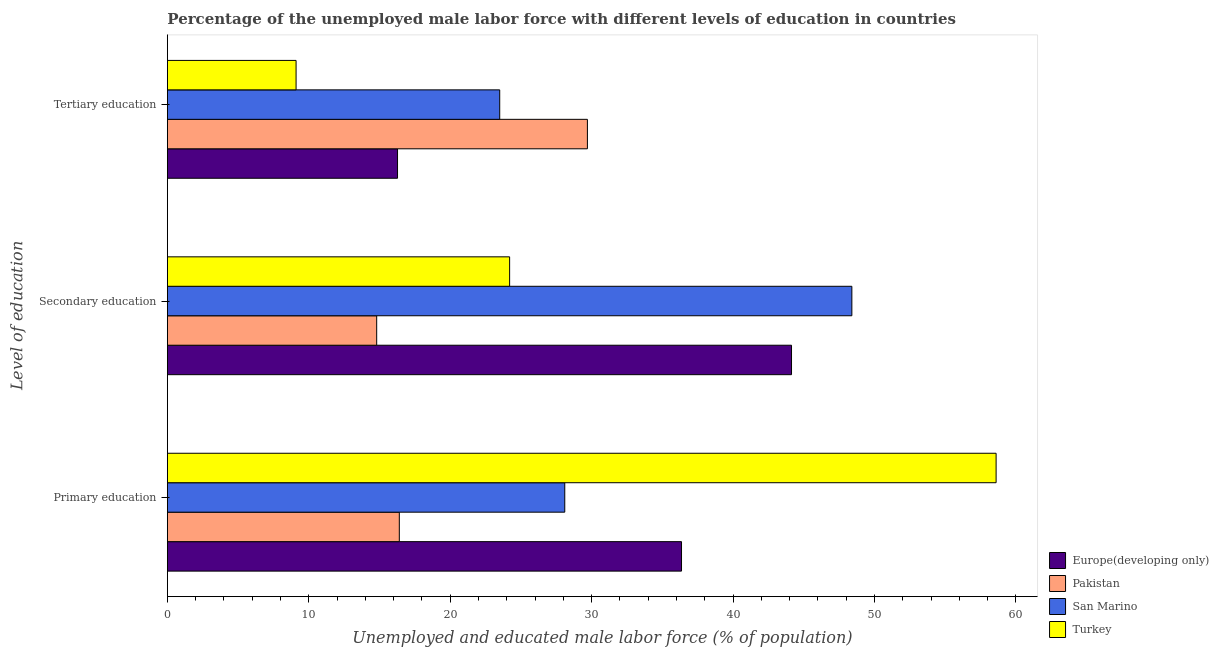Are the number of bars per tick equal to the number of legend labels?
Your answer should be very brief. Yes. How many bars are there on the 2nd tick from the bottom?
Offer a terse response. 4. What is the label of the 1st group of bars from the top?
Offer a terse response. Tertiary education. What is the percentage of male labor force who received secondary education in Pakistan?
Give a very brief answer. 14.8. Across all countries, what is the maximum percentage of male labor force who received secondary education?
Provide a short and direct response. 48.4. Across all countries, what is the minimum percentage of male labor force who received primary education?
Make the answer very short. 16.4. In which country was the percentage of male labor force who received primary education maximum?
Your response must be concise. Turkey. What is the total percentage of male labor force who received primary education in the graph?
Give a very brief answer. 139.46. What is the difference between the percentage of male labor force who received primary education in Pakistan and that in San Marino?
Your answer should be very brief. -11.7. What is the difference between the percentage of male labor force who received tertiary education in Europe(developing only) and the percentage of male labor force who received secondary education in San Marino?
Offer a very short reply. -32.13. What is the average percentage of male labor force who received tertiary education per country?
Offer a terse response. 19.64. What is the difference between the percentage of male labor force who received tertiary education and percentage of male labor force who received secondary education in Turkey?
Keep it short and to the point. -15.1. What is the ratio of the percentage of male labor force who received tertiary education in Europe(developing only) to that in San Marino?
Your response must be concise. 0.69. Is the percentage of male labor force who received secondary education in San Marino less than that in Turkey?
Provide a succinct answer. No. What is the difference between the highest and the second highest percentage of male labor force who received tertiary education?
Provide a short and direct response. 6.2. What is the difference between the highest and the lowest percentage of male labor force who received tertiary education?
Give a very brief answer. 20.6. What does the 2nd bar from the top in Primary education represents?
Provide a short and direct response. San Marino. What does the 2nd bar from the bottom in Primary education represents?
Your answer should be compact. Pakistan. How many bars are there?
Give a very brief answer. 12. Are all the bars in the graph horizontal?
Make the answer very short. Yes. How many countries are there in the graph?
Offer a terse response. 4. What is the difference between two consecutive major ticks on the X-axis?
Provide a succinct answer. 10. Are the values on the major ticks of X-axis written in scientific E-notation?
Make the answer very short. No. Does the graph contain grids?
Keep it short and to the point. No. What is the title of the graph?
Ensure brevity in your answer.  Percentage of the unemployed male labor force with different levels of education in countries. Does "Tanzania" appear as one of the legend labels in the graph?
Provide a short and direct response. No. What is the label or title of the X-axis?
Give a very brief answer. Unemployed and educated male labor force (% of population). What is the label or title of the Y-axis?
Offer a very short reply. Level of education. What is the Unemployed and educated male labor force (% of population) in Europe(developing only) in Primary education?
Your answer should be very brief. 36.36. What is the Unemployed and educated male labor force (% of population) in Pakistan in Primary education?
Provide a short and direct response. 16.4. What is the Unemployed and educated male labor force (% of population) of San Marino in Primary education?
Offer a very short reply. 28.1. What is the Unemployed and educated male labor force (% of population) in Turkey in Primary education?
Provide a succinct answer. 58.6. What is the Unemployed and educated male labor force (% of population) in Europe(developing only) in Secondary education?
Give a very brief answer. 44.13. What is the Unemployed and educated male labor force (% of population) in Pakistan in Secondary education?
Offer a very short reply. 14.8. What is the Unemployed and educated male labor force (% of population) of San Marino in Secondary education?
Provide a short and direct response. 48.4. What is the Unemployed and educated male labor force (% of population) of Turkey in Secondary education?
Make the answer very short. 24.2. What is the Unemployed and educated male labor force (% of population) in Europe(developing only) in Tertiary education?
Make the answer very short. 16.27. What is the Unemployed and educated male labor force (% of population) of Pakistan in Tertiary education?
Ensure brevity in your answer.  29.7. What is the Unemployed and educated male labor force (% of population) in San Marino in Tertiary education?
Make the answer very short. 23.5. What is the Unemployed and educated male labor force (% of population) in Turkey in Tertiary education?
Your answer should be very brief. 9.1. Across all Level of education, what is the maximum Unemployed and educated male labor force (% of population) in Europe(developing only)?
Ensure brevity in your answer.  44.13. Across all Level of education, what is the maximum Unemployed and educated male labor force (% of population) of Pakistan?
Provide a succinct answer. 29.7. Across all Level of education, what is the maximum Unemployed and educated male labor force (% of population) of San Marino?
Keep it short and to the point. 48.4. Across all Level of education, what is the maximum Unemployed and educated male labor force (% of population) in Turkey?
Make the answer very short. 58.6. Across all Level of education, what is the minimum Unemployed and educated male labor force (% of population) in Europe(developing only)?
Provide a succinct answer. 16.27. Across all Level of education, what is the minimum Unemployed and educated male labor force (% of population) of Pakistan?
Your response must be concise. 14.8. Across all Level of education, what is the minimum Unemployed and educated male labor force (% of population) in San Marino?
Give a very brief answer. 23.5. Across all Level of education, what is the minimum Unemployed and educated male labor force (% of population) in Turkey?
Your response must be concise. 9.1. What is the total Unemployed and educated male labor force (% of population) in Europe(developing only) in the graph?
Give a very brief answer. 96.76. What is the total Unemployed and educated male labor force (% of population) of Pakistan in the graph?
Provide a succinct answer. 60.9. What is the total Unemployed and educated male labor force (% of population) in San Marino in the graph?
Your answer should be very brief. 100. What is the total Unemployed and educated male labor force (% of population) in Turkey in the graph?
Your answer should be compact. 91.9. What is the difference between the Unemployed and educated male labor force (% of population) in Europe(developing only) in Primary education and that in Secondary education?
Keep it short and to the point. -7.78. What is the difference between the Unemployed and educated male labor force (% of population) of Pakistan in Primary education and that in Secondary education?
Give a very brief answer. 1.6. What is the difference between the Unemployed and educated male labor force (% of population) of San Marino in Primary education and that in Secondary education?
Make the answer very short. -20.3. What is the difference between the Unemployed and educated male labor force (% of population) in Turkey in Primary education and that in Secondary education?
Your answer should be compact. 34.4. What is the difference between the Unemployed and educated male labor force (% of population) of Europe(developing only) in Primary education and that in Tertiary education?
Your response must be concise. 20.08. What is the difference between the Unemployed and educated male labor force (% of population) in Turkey in Primary education and that in Tertiary education?
Offer a terse response. 49.5. What is the difference between the Unemployed and educated male labor force (% of population) of Europe(developing only) in Secondary education and that in Tertiary education?
Provide a short and direct response. 27.86. What is the difference between the Unemployed and educated male labor force (% of population) of Pakistan in Secondary education and that in Tertiary education?
Give a very brief answer. -14.9. What is the difference between the Unemployed and educated male labor force (% of population) in San Marino in Secondary education and that in Tertiary education?
Your answer should be very brief. 24.9. What is the difference between the Unemployed and educated male labor force (% of population) in Turkey in Secondary education and that in Tertiary education?
Provide a succinct answer. 15.1. What is the difference between the Unemployed and educated male labor force (% of population) of Europe(developing only) in Primary education and the Unemployed and educated male labor force (% of population) of Pakistan in Secondary education?
Provide a short and direct response. 21.56. What is the difference between the Unemployed and educated male labor force (% of population) of Europe(developing only) in Primary education and the Unemployed and educated male labor force (% of population) of San Marino in Secondary education?
Your response must be concise. -12.04. What is the difference between the Unemployed and educated male labor force (% of population) in Europe(developing only) in Primary education and the Unemployed and educated male labor force (% of population) in Turkey in Secondary education?
Offer a very short reply. 12.16. What is the difference between the Unemployed and educated male labor force (% of population) of Pakistan in Primary education and the Unemployed and educated male labor force (% of population) of San Marino in Secondary education?
Offer a terse response. -32. What is the difference between the Unemployed and educated male labor force (% of population) in San Marino in Primary education and the Unemployed and educated male labor force (% of population) in Turkey in Secondary education?
Your response must be concise. 3.9. What is the difference between the Unemployed and educated male labor force (% of population) in Europe(developing only) in Primary education and the Unemployed and educated male labor force (% of population) in Pakistan in Tertiary education?
Your response must be concise. 6.66. What is the difference between the Unemployed and educated male labor force (% of population) of Europe(developing only) in Primary education and the Unemployed and educated male labor force (% of population) of San Marino in Tertiary education?
Ensure brevity in your answer.  12.86. What is the difference between the Unemployed and educated male labor force (% of population) in Europe(developing only) in Primary education and the Unemployed and educated male labor force (% of population) in Turkey in Tertiary education?
Your response must be concise. 27.26. What is the difference between the Unemployed and educated male labor force (% of population) in Pakistan in Primary education and the Unemployed and educated male labor force (% of population) in San Marino in Tertiary education?
Ensure brevity in your answer.  -7.1. What is the difference between the Unemployed and educated male labor force (% of population) in Pakistan in Primary education and the Unemployed and educated male labor force (% of population) in Turkey in Tertiary education?
Keep it short and to the point. 7.3. What is the difference between the Unemployed and educated male labor force (% of population) of San Marino in Primary education and the Unemployed and educated male labor force (% of population) of Turkey in Tertiary education?
Give a very brief answer. 19. What is the difference between the Unemployed and educated male labor force (% of population) of Europe(developing only) in Secondary education and the Unemployed and educated male labor force (% of population) of Pakistan in Tertiary education?
Provide a short and direct response. 14.43. What is the difference between the Unemployed and educated male labor force (% of population) in Europe(developing only) in Secondary education and the Unemployed and educated male labor force (% of population) in San Marino in Tertiary education?
Your answer should be very brief. 20.63. What is the difference between the Unemployed and educated male labor force (% of population) in Europe(developing only) in Secondary education and the Unemployed and educated male labor force (% of population) in Turkey in Tertiary education?
Give a very brief answer. 35.03. What is the difference between the Unemployed and educated male labor force (% of population) of Pakistan in Secondary education and the Unemployed and educated male labor force (% of population) of Turkey in Tertiary education?
Your answer should be very brief. 5.7. What is the difference between the Unemployed and educated male labor force (% of population) in San Marino in Secondary education and the Unemployed and educated male labor force (% of population) in Turkey in Tertiary education?
Offer a terse response. 39.3. What is the average Unemployed and educated male labor force (% of population) of Europe(developing only) per Level of education?
Keep it short and to the point. 32.25. What is the average Unemployed and educated male labor force (% of population) in Pakistan per Level of education?
Your answer should be compact. 20.3. What is the average Unemployed and educated male labor force (% of population) of San Marino per Level of education?
Your answer should be very brief. 33.33. What is the average Unemployed and educated male labor force (% of population) of Turkey per Level of education?
Your answer should be very brief. 30.63. What is the difference between the Unemployed and educated male labor force (% of population) in Europe(developing only) and Unemployed and educated male labor force (% of population) in Pakistan in Primary education?
Your answer should be very brief. 19.96. What is the difference between the Unemployed and educated male labor force (% of population) in Europe(developing only) and Unemployed and educated male labor force (% of population) in San Marino in Primary education?
Ensure brevity in your answer.  8.26. What is the difference between the Unemployed and educated male labor force (% of population) in Europe(developing only) and Unemployed and educated male labor force (% of population) in Turkey in Primary education?
Your response must be concise. -22.24. What is the difference between the Unemployed and educated male labor force (% of population) of Pakistan and Unemployed and educated male labor force (% of population) of Turkey in Primary education?
Give a very brief answer. -42.2. What is the difference between the Unemployed and educated male labor force (% of population) of San Marino and Unemployed and educated male labor force (% of population) of Turkey in Primary education?
Provide a succinct answer. -30.5. What is the difference between the Unemployed and educated male labor force (% of population) of Europe(developing only) and Unemployed and educated male labor force (% of population) of Pakistan in Secondary education?
Keep it short and to the point. 29.33. What is the difference between the Unemployed and educated male labor force (% of population) in Europe(developing only) and Unemployed and educated male labor force (% of population) in San Marino in Secondary education?
Make the answer very short. -4.27. What is the difference between the Unemployed and educated male labor force (% of population) in Europe(developing only) and Unemployed and educated male labor force (% of population) in Turkey in Secondary education?
Keep it short and to the point. 19.93. What is the difference between the Unemployed and educated male labor force (% of population) in Pakistan and Unemployed and educated male labor force (% of population) in San Marino in Secondary education?
Offer a terse response. -33.6. What is the difference between the Unemployed and educated male labor force (% of population) in San Marino and Unemployed and educated male labor force (% of population) in Turkey in Secondary education?
Ensure brevity in your answer.  24.2. What is the difference between the Unemployed and educated male labor force (% of population) in Europe(developing only) and Unemployed and educated male labor force (% of population) in Pakistan in Tertiary education?
Your answer should be very brief. -13.43. What is the difference between the Unemployed and educated male labor force (% of population) in Europe(developing only) and Unemployed and educated male labor force (% of population) in San Marino in Tertiary education?
Your answer should be compact. -7.23. What is the difference between the Unemployed and educated male labor force (% of population) of Europe(developing only) and Unemployed and educated male labor force (% of population) of Turkey in Tertiary education?
Keep it short and to the point. 7.17. What is the difference between the Unemployed and educated male labor force (% of population) of Pakistan and Unemployed and educated male labor force (% of population) of Turkey in Tertiary education?
Offer a very short reply. 20.6. What is the difference between the Unemployed and educated male labor force (% of population) in San Marino and Unemployed and educated male labor force (% of population) in Turkey in Tertiary education?
Give a very brief answer. 14.4. What is the ratio of the Unemployed and educated male labor force (% of population) of Europe(developing only) in Primary education to that in Secondary education?
Your answer should be compact. 0.82. What is the ratio of the Unemployed and educated male labor force (% of population) of Pakistan in Primary education to that in Secondary education?
Keep it short and to the point. 1.11. What is the ratio of the Unemployed and educated male labor force (% of population) in San Marino in Primary education to that in Secondary education?
Your answer should be very brief. 0.58. What is the ratio of the Unemployed and educated male labor force (% of population) of Turkey in Primary education to that in Secondary education?
Ensure brevity in your answer.  2.42. What is the ratio of the Unemployed and educated male labor force (% of population) of Europe(developing only) in Primary education to that in Tertiary education?
Your answer should be very brief. 2.23. What is the ratio of the Unemployed and educated male labor force (% of population) of Pakistan in Primary education to that in Tertiary education?
Give a very brief answer. 0.55. What is the ratio of the Unemployed and educated male labor force (% of population) in San Marino in Primary education to that in Tertiary education?
Your answer should be very brief. 1.2. What is the ratio of the Unemployed and educated male labor force (% of population) in Turkey in Primary education to that in Tertiary education?
Keep it short and to the point. 6.44. What is the ratio of the Unemployed and educated male labor force (% of population) in Europe(developing only) in Secondary education to that in Tertiary education?
Your answer should be very brief. 2.71. What is the ratio of the Unemployed and educated male labor force (% of population) in Pakistan in Secondary education to that in Tertiary education?
Your answer should be compact. 0.5. What is the ratio of the Unemployed and educated male labor force (% of population) of San Marino in Secondary education to that in Tertiary education?
Provide a short and direct response. 2.06. What is the ratio of the Unemployed and educated male labor force (% of population) in Turkey in Secondary education to that in Tertiary education?
Your response must be concise. 2.66. What is the difference between the highest and the second highest Unemployed and educated male labor force (% of population) in Europe(developing only)?
Your answer should be compact. 7.78. What is the difference between the highest and the second highest Unemployed and educated male labor force (% of population) in San Marino?
Your answer should be very brief. 20.3. What is the difference between the highest and the second highest Unemployed and educated male labor force (% of population) in Turkey?
Ensure brevity in your answer.  34.4. What is the difference between the highest and the lowest Unemployed and educated male labor force (% of population) in Europe(developing only)?
Your response must be concise. 27.86. What is the difference between the highest and the lowest Unemployed and educated male labor force (% of population) of San Marino?
Offer a terse response. 24.9. What is the difference between the highest and the lowest Unemployed and educated male labor force (% of population) in Turkey?
Ensure brevity in your answer.  49.5. 